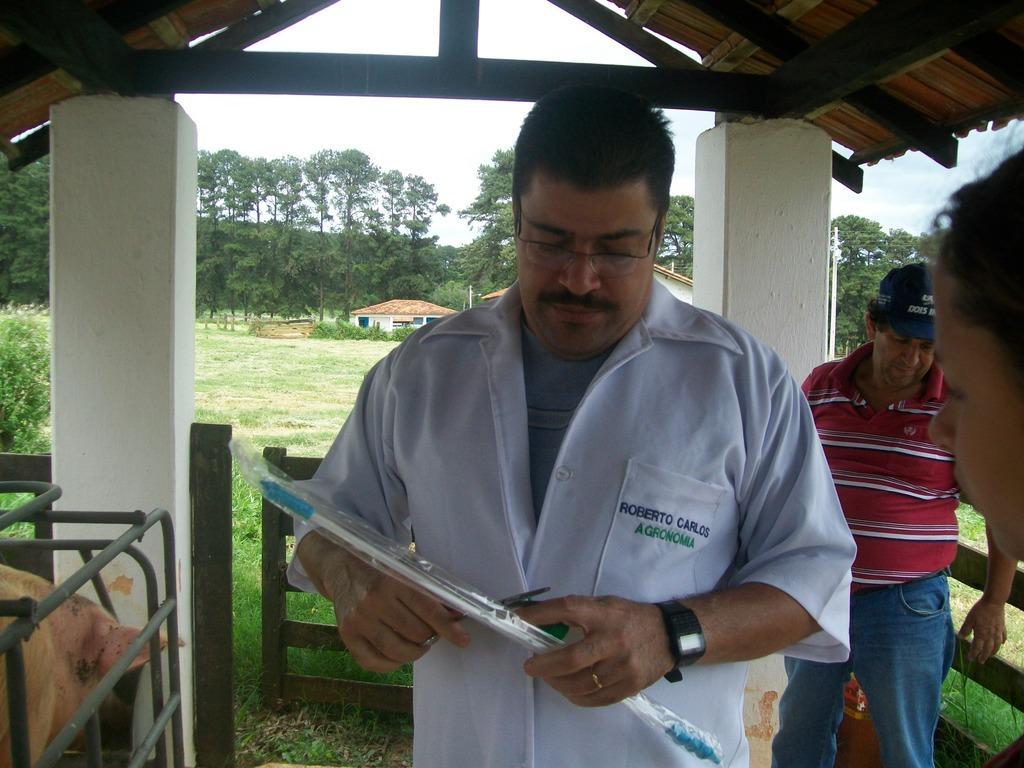Describe this image in one or two sentences. Here in this picture we can see a group of people standing on the ground and the person in the middle is holding something in his hand and wearing spectacles and we can see the ground is full covered with grass and beside them we can see railing present and on the left side we can see some animals present and above them we can see a shed present and in the far we can see plants and trees present and we can also see a house present and we can see the sky is cloudy. 